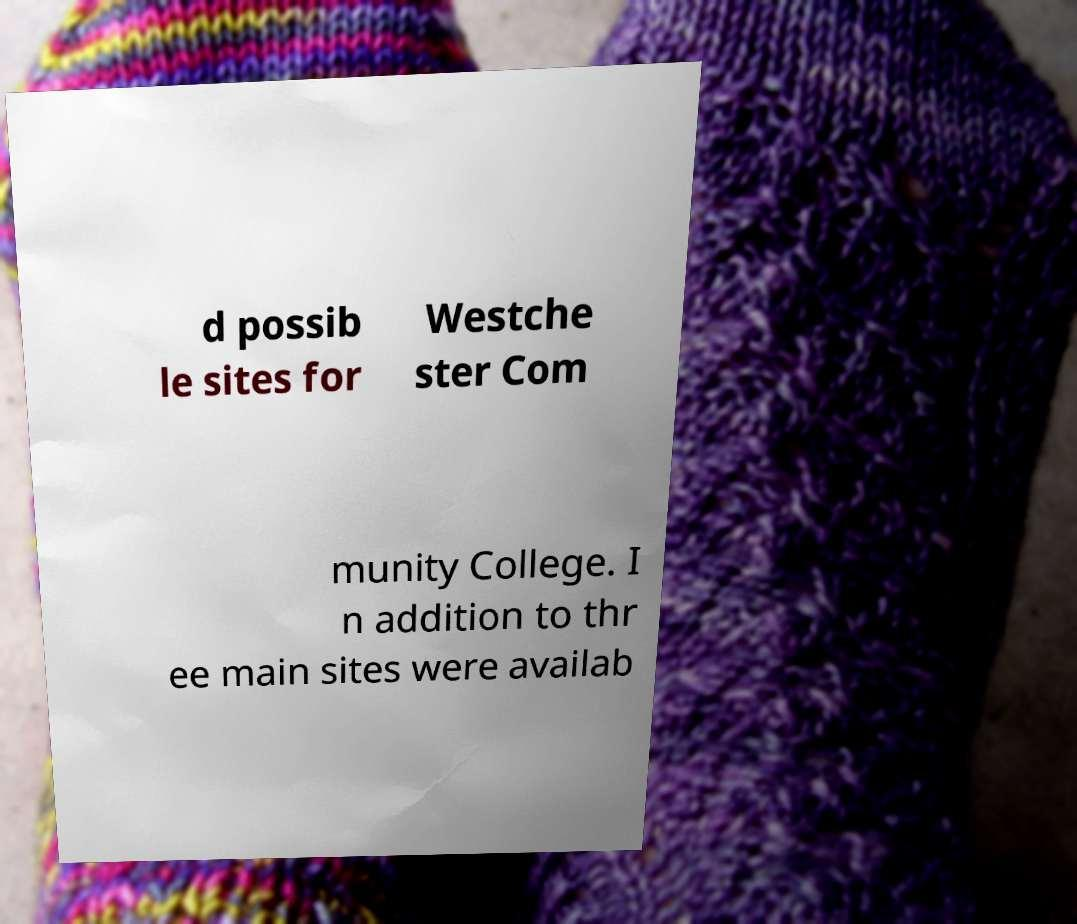Can you accurately transcribe the text from the provided image for me? d possib le sites for Westche ster Com munity College. I n addition to thr ee main sites were availab 